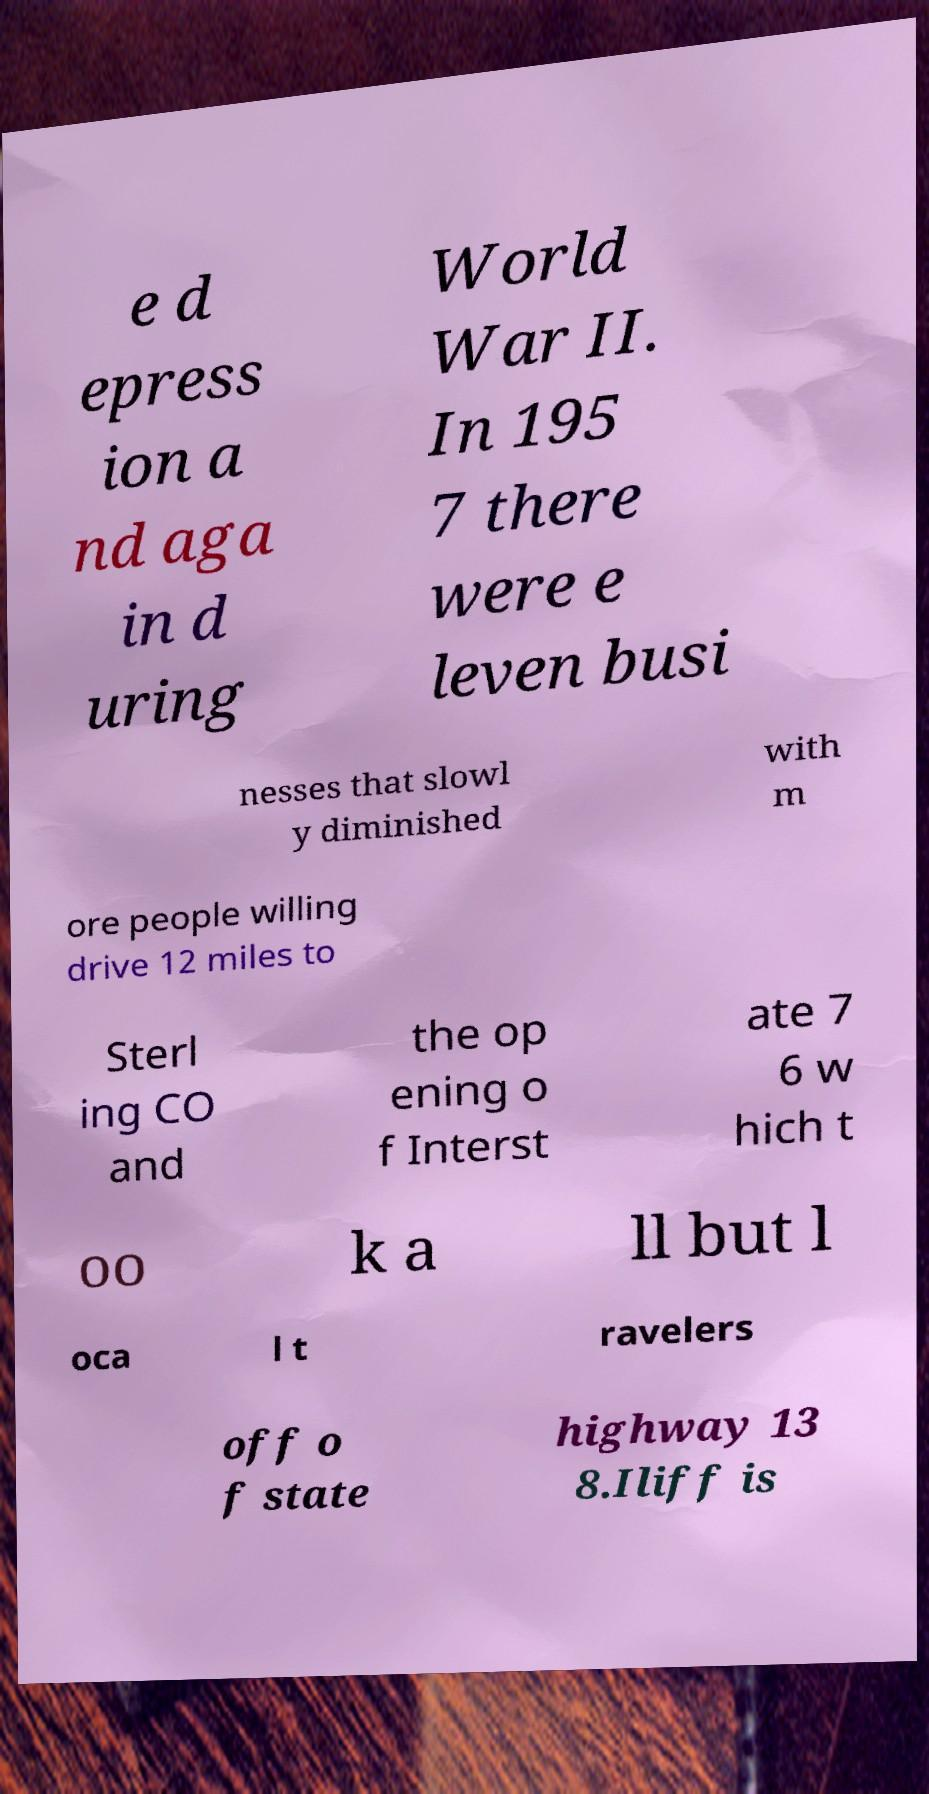Please read and relay the text visible in this image. What does it say? e d epress ion a nd aga in d uring World War II. In 195 7 there were e leven busi nesses that slowl y diminished with m ore people willing drive 12 miles to Sterl ing CO and the op ening o f Interst ate 7 6 w hich t oo k a ll but l oca l t ravelers off o f state highway 13 8.Iliff is 